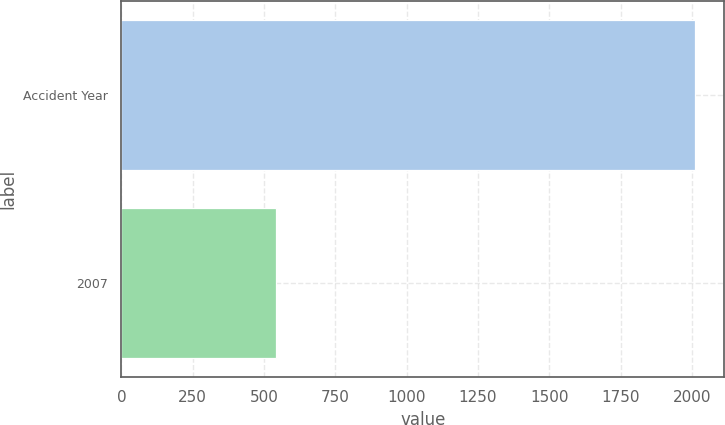<chart> <loc_0><loc_0><loc_500><loc_500><bar_chart><fcel>Accident Year<fcel>2007<nl><fcel>2012<fcel>542<nl></chart> 